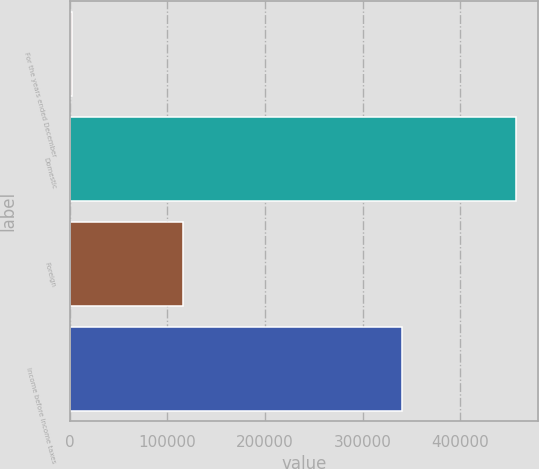Convert chart to OTSL. <chart><loc_0><loc_0><loc_500><loc_500><bar_chart><fcel>For the years ended December<fcel>Domestic<fcel>Foreign<fcel>Income before income taxes<nl><fcel>2007<fcel>456856<fcel>116614<fcel>340242<nl></chart> 